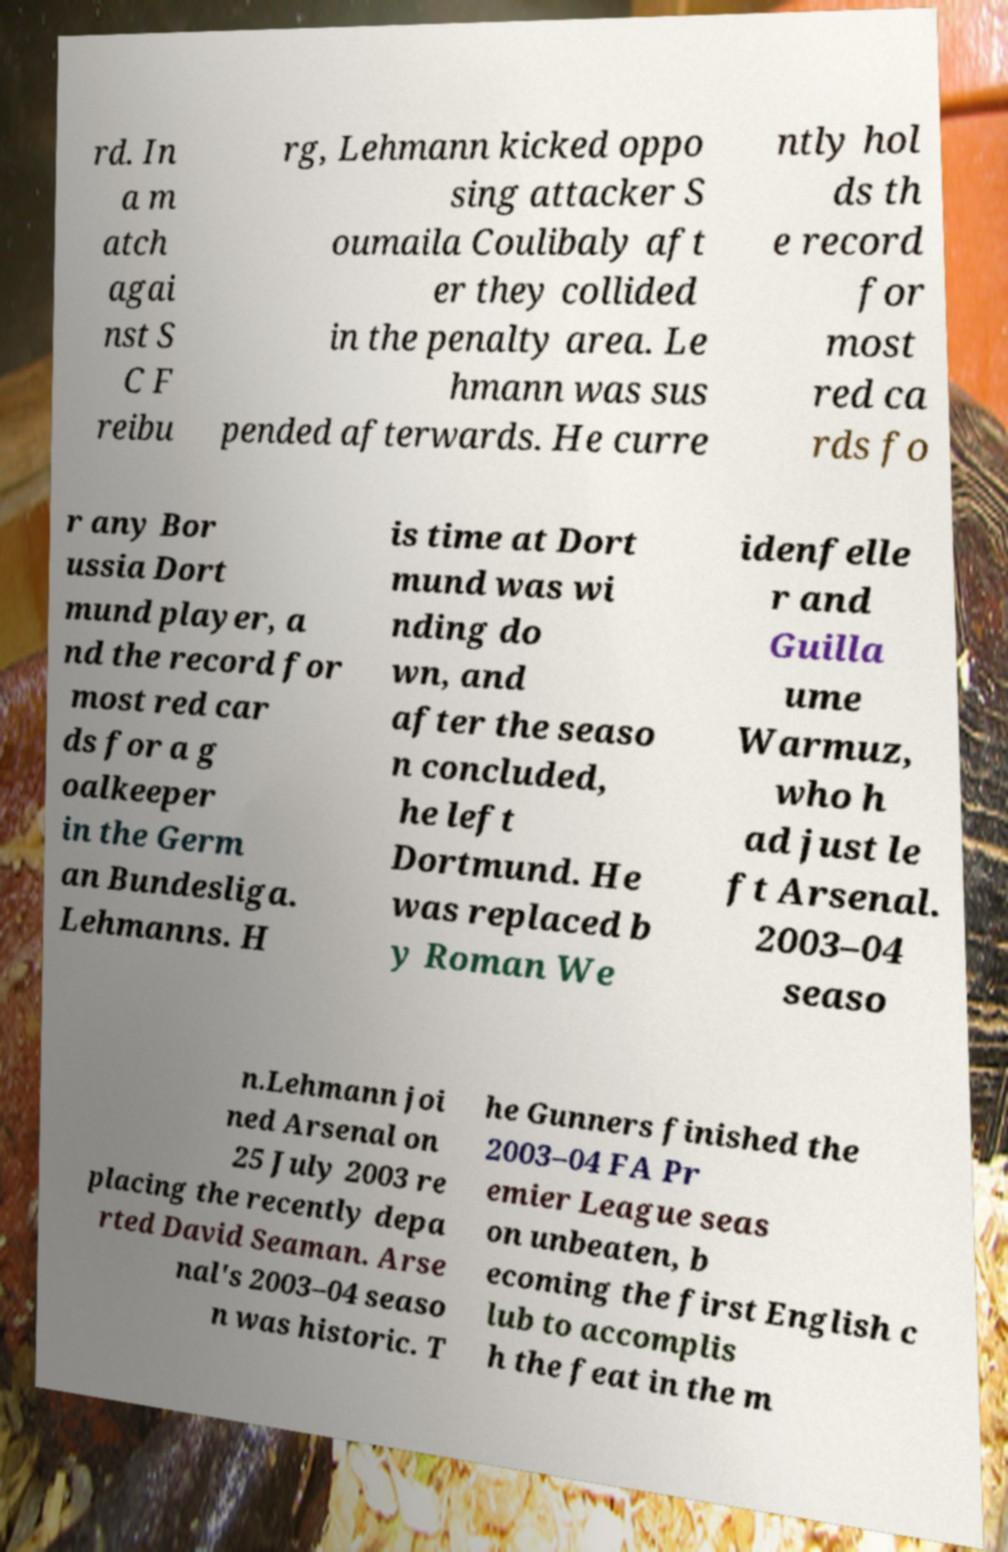Please read and relay the text visible in this image. What does it say? rd. In a m atch agai nst S C F reibu rg, Lehmann kicked oppo sing attacker S oumaila Coulibaly aft er they collided in the penalty area. Le hmann was sus pended afterwards. He curre ntly hol ds th e record for most red ca rds fo r any Bor ussia Dort mund player, a nd the record for most red car ds for a g oalkeeper in the Germ an Bundesliga. Lehmanns. H is time at Dort mund was wi nding do wn, and after the seaso n concluded, he left Dortmund. He was replaced b y Roman We idenfelle r and Guilla ume Warmuz, who h ad just le ft Arsenal. 2003–04 seaso n.Lehmann joi ned Arsenal on 25 July 2003 re placing the recently depa rted David Seaman. Arse nal's 2003–04 seaso n was historic. T he Gunners finished the 2003–04 FA Pr emier League seas on unbeaten, b ecoming the first English c lub to accomplis h the feat in the m 